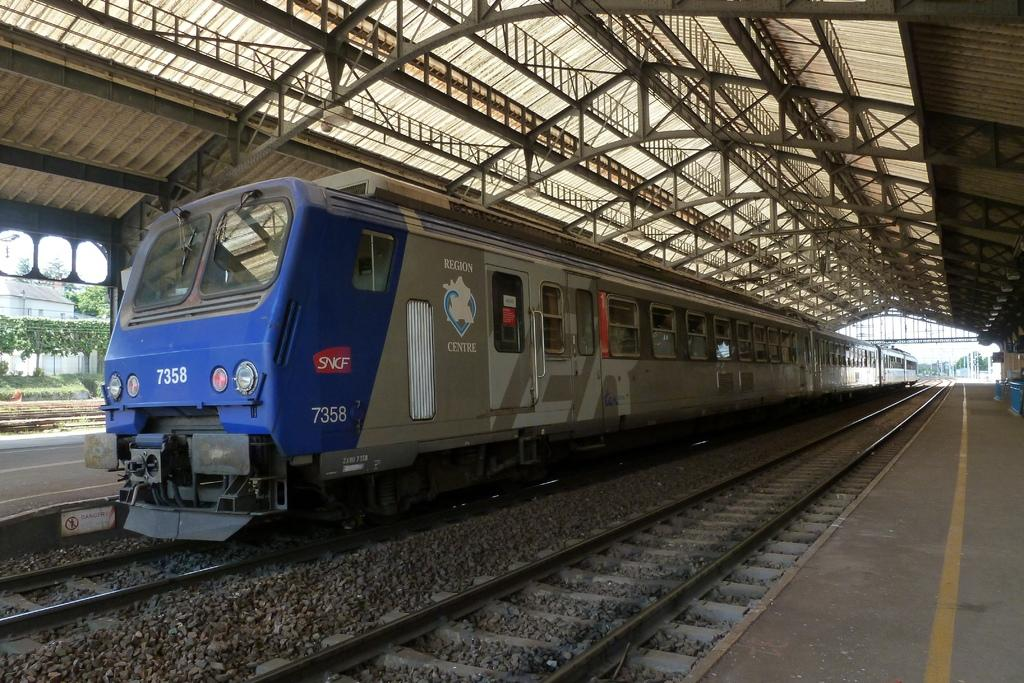What is the main subject of the image? There is a train in the image. Where is the train located? The train is on a railway track. What colors can be seen on the train? The train is blue and ash colored. What type of vegetation is visible in the image? There are trees visible in the image. What structure can be seen in the image? There is a shed in the image. What else can be seen in the image besides the train and trees? There are poles in the image. What objects might be found on the platform near the train? There are objects on the platform in the image. Can you tell me how many yaks are grazing near the train in the image? There are no yaks present in the image. What type of basket is hanging from the train's window in the image? There is no basket hanging from the train's window in the image. 